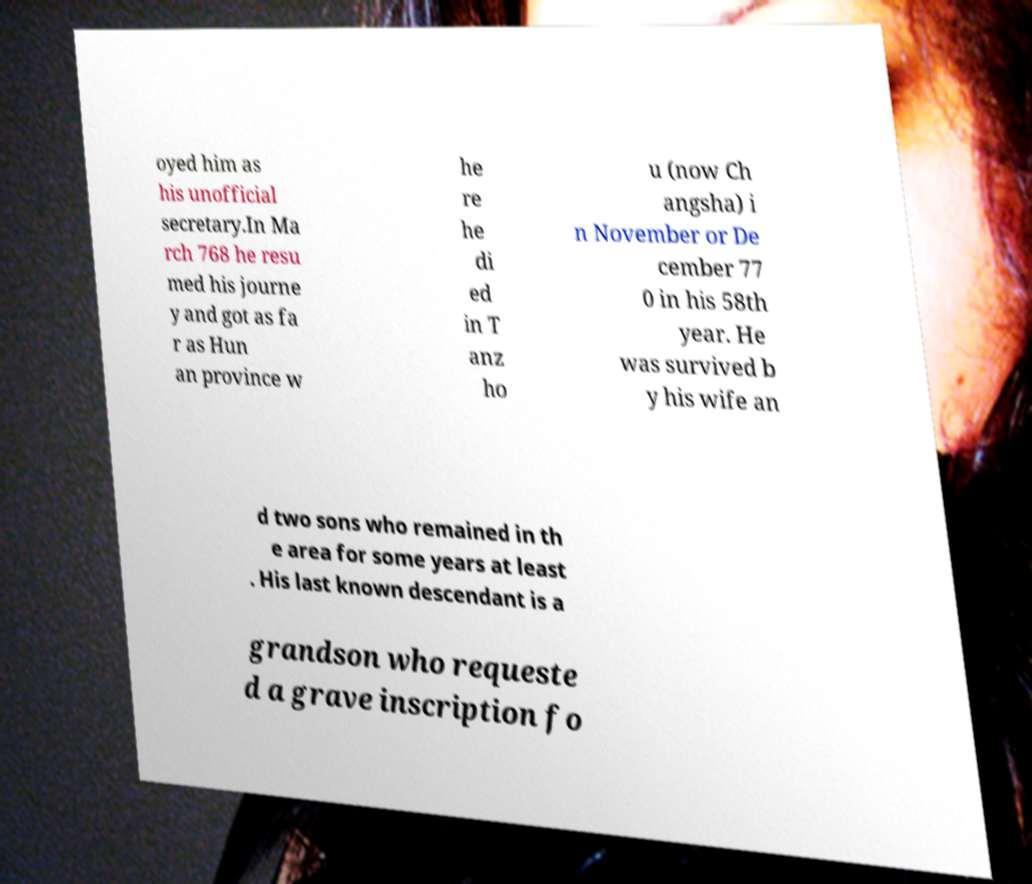Could you assist in decoding the text presented in this image and type it out clearly? oyed him as his unofficial secretary.In Ma rch 768 he resu med his journe y and got as fa r as Hun an province w he re he di ed in T anz ho u (now Ch angsha) i n November or De cember 77 0 in his 58th year. He was survived b y his wife an d two sons who remained in th e area for some years at least . His last known descendant is a grandson who requeste d a grave inscription fo 